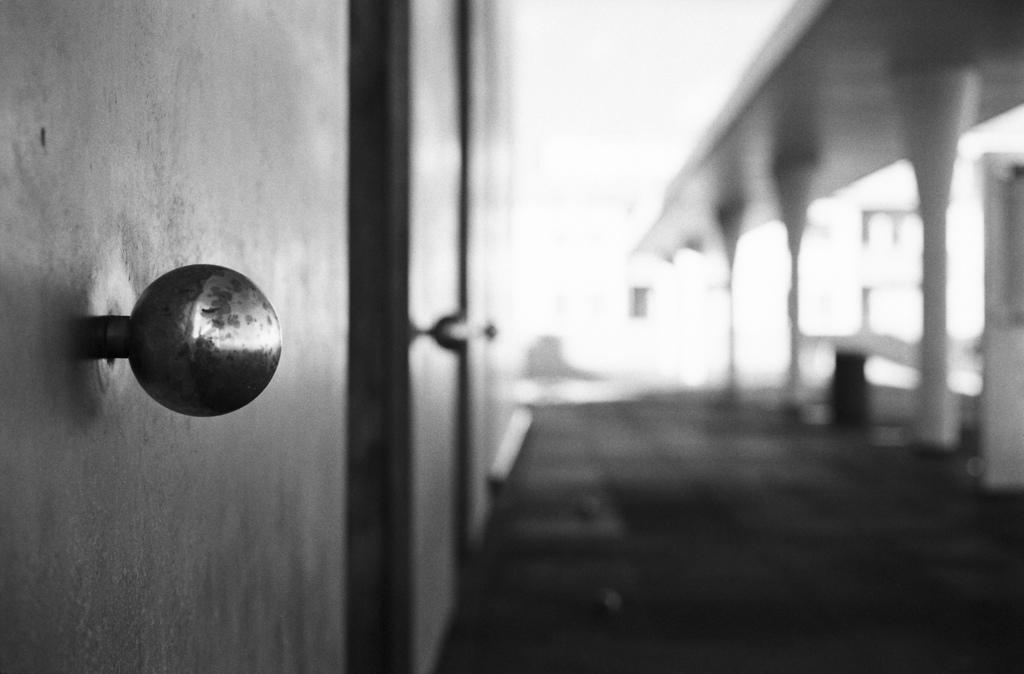What is the color scheme of the image? The image is black and white. What type of objects can be seen in the image? There are doors with door knobs in the image. Can you describe the background of the image? The background of the image is blurred. How many tails can be seen on the doors in the image? There are no tails present on the doors in the image. What type of ticket is required to enter the room in the image? There is no mention of a ticket or any requirement to enter the room in the image. 